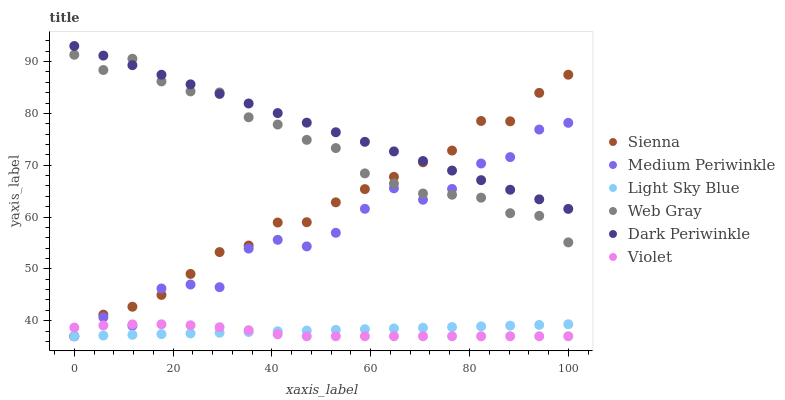Does Violet have the minimum area under the curve?
Answer yes or no. Yes. Does Dark Periwinkle have the maximum area under the curve?
Answer yes or no. Yes. Does Medium Periwinkle have the minimum area under the curve?
Answer yes or no. No. Does Medium Periwinkle have the maximum area under the curve?
Answer yes or no. No. Is Light Sky Blue the smoothest?
Answer yes or no. Yes. Is Medium Periwinkle the roughest?
Answer yes or no. Yes. Is Sienna the smoothest?
Answer yes or no. No. Is Sienna the roughest?
Answer yes or no. No. Does Medium Periwinkle have the lowest value?
Answer yes or no. Yes. Does Dark Periwinkle have the lowest value?
Answer yes or no. No. Does Dark Periwinkle have the highest value?
Answer yes or no. Yes. Does Medium Periwinkle have the highest value?
Answer yes or no. No. Is Violet less than Web Gray?
Answer yes or no. Yes. Is Dark Periwinkle greater than Violet?
Answer yes or no. Yes. Does Light Sky Blue intersect Medium Periwinkle?
Answer yes or no. Yes. Is Light Sky Blue less than Medium Periwinkle?
Answer yes or no. No. Is Light Sky Blue greater than Medium Periwinkle?
Answer yes or no. No. Does Violet intersect Web Gray?
Answer yes or no. No. 